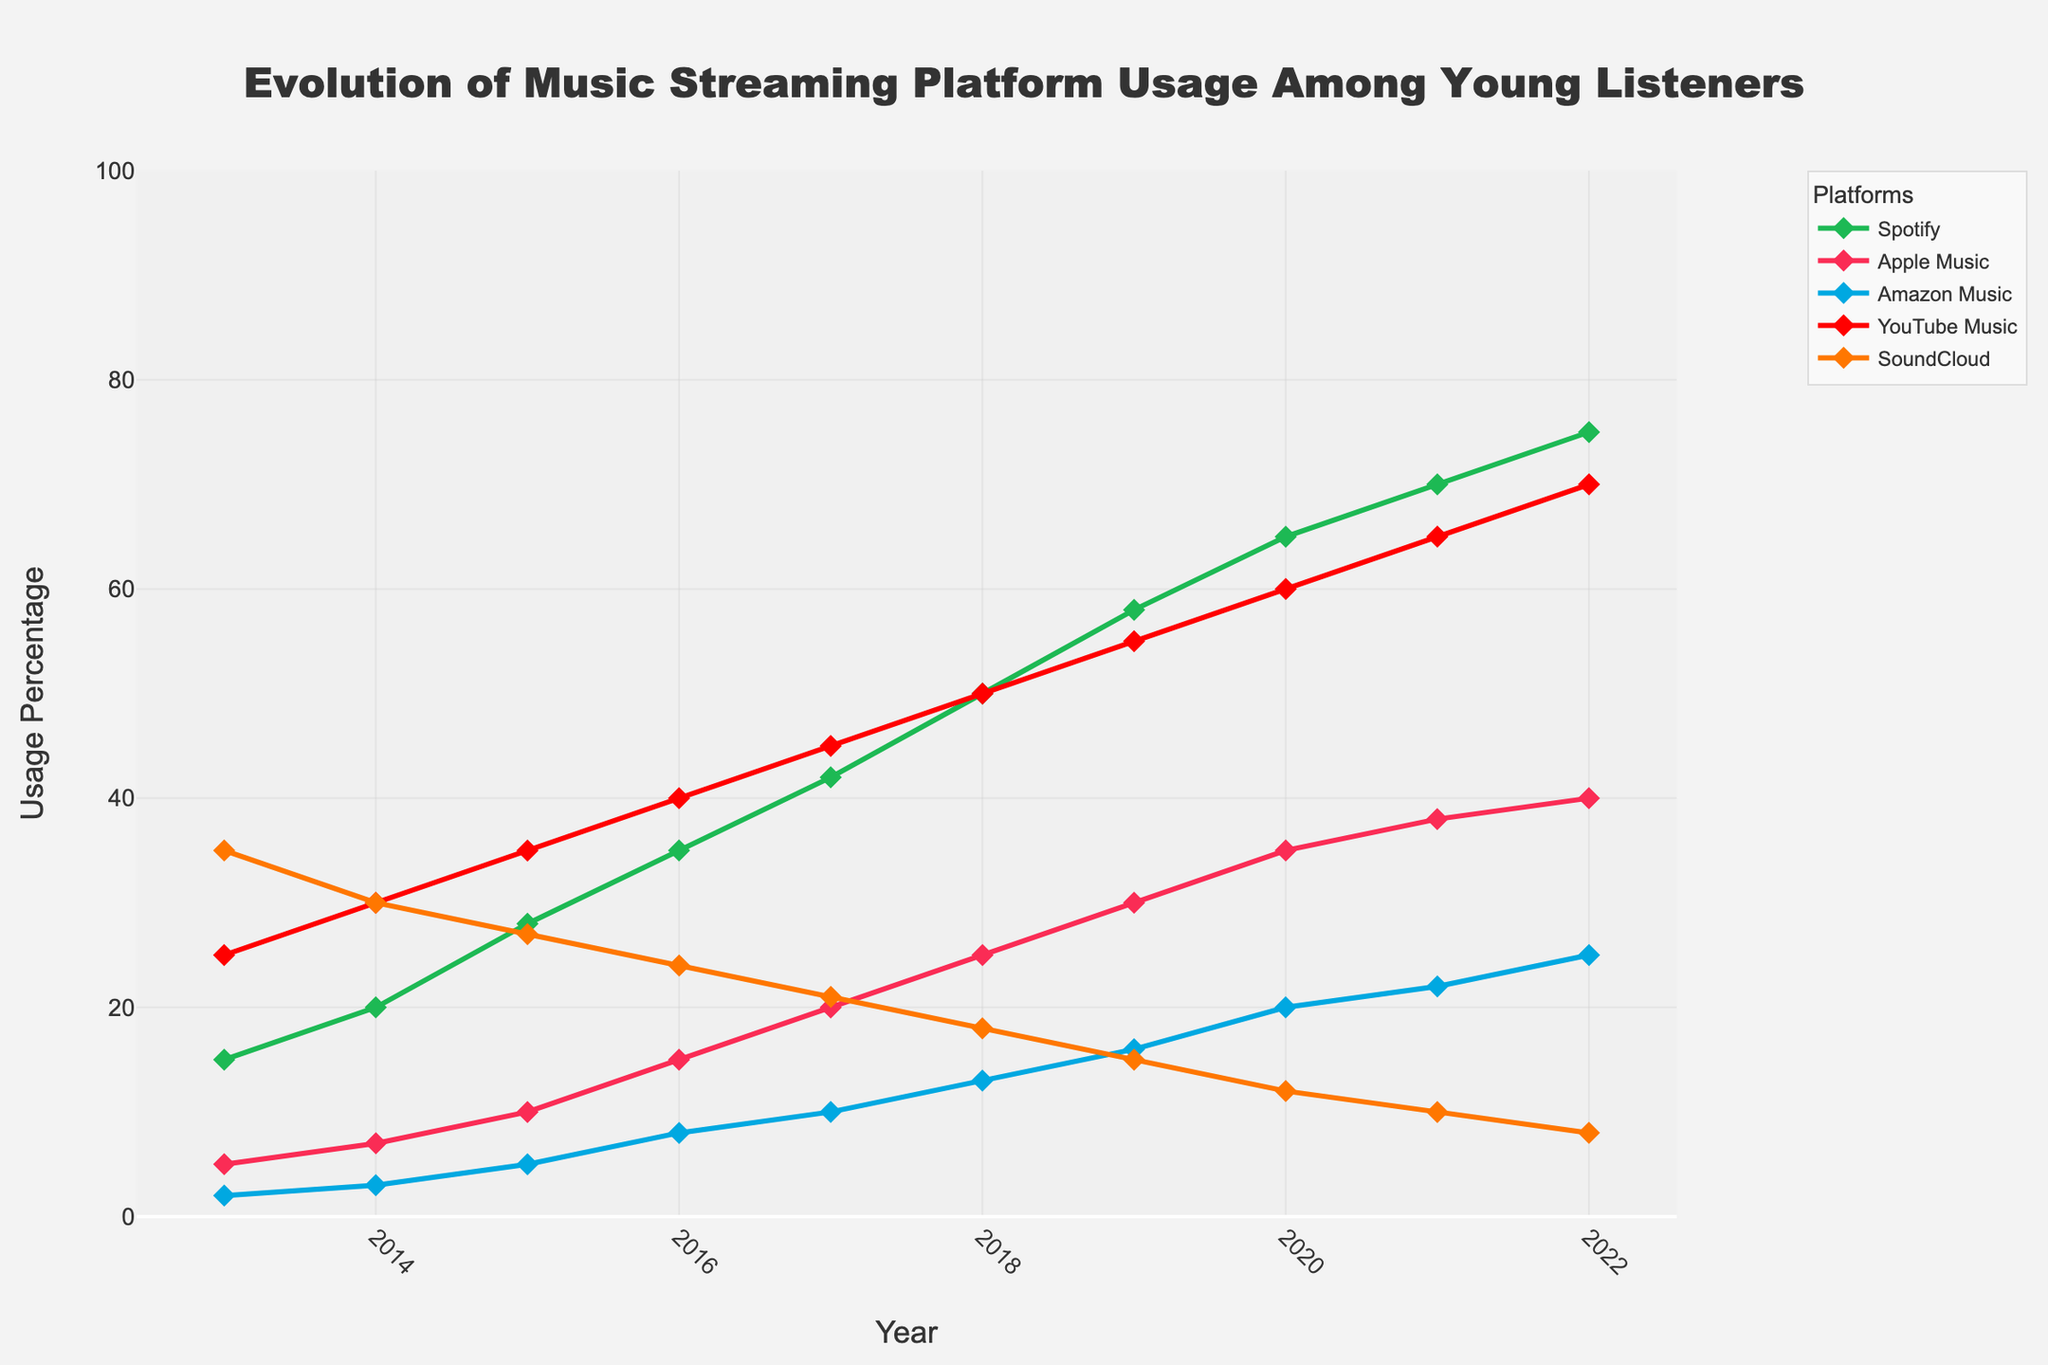What is the dominant music streaming platform in 2022? In 2022, the platform with the highest usage percentage should be identified from the figure. This is the platform with the tallest marker in 2022.
Answer: Spotify How has YouTube Music's usage changed from 2013 to 2022? Look at the markers for YouTube Music in 2013 and 2022. Note the percentage value for each year and calculate the difference.
Answer: It increased by 45 percentage points Which platform had the steepest rise in usage over the 10-year period? Evaluate the slopes of the trend lines for each platform. The platform with the steepest rise will have the greatest difference in usage percentage between 2013 and 2022.
Answer: Spotify In which year did Apple Music surpass Amazon Music in usage? Find the intersection point of Apple Music and Amazon Music lines. The year at which Apple Music's line goes above Amazon Music's line indicates the surpassing point.
Answer: 2015 Across the entire period shown, which platform saw the most significant decline in usage? Examine the trend lines for each platform and identify the one with the most downward slope over the 10-year period.
Answer: SoundCloud What trends can be observed with SoundCloud usage from 2013 to 2022? Observe the trend line for SoundCloud from the beginning year to the end year. Note any changes in direction or slope.
Answer: Steadily declined What was the average usage of Spotify over the 10 years? Add up the percentages for Spotify from each year and divide by the number of years to find the average.
Answer: 45.8 Which years saw the highest and lowest total usage of all platforms combined? Sum the usage percentages of all platforms for each year and compare to find the highest and lowest totals.
Answer: Highest: 2022, Lowest: 2013 How does the usage of Apple Music in 2017 compare to its usage in 2022? Compare the markers for Apple Music in 2017 and 2022 and note the difference in their heights.
Answer: Increased by 20 percentage points Between which consecutive years did Amazon Music see the greatest increase in usage? Look at the Amazon Music line and find the segment between consecutive years with the steepest slope by calculating the difference.
Answer: 2019 to 2020 